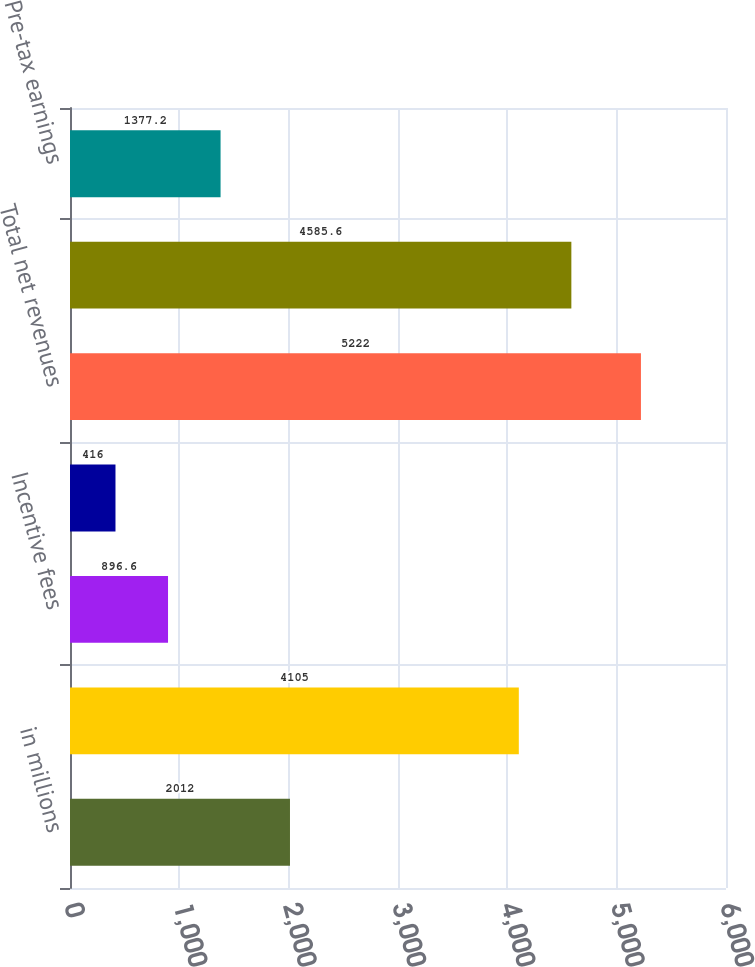Convert chart. <chart><loc_0><loc_0><loc_500><loc_500><bar_chart><fcel>in millions<fcel>Management and other fees<fcel>Incentive fees<fcel>Transaction revenues<fcel>Total net revenues<fcel>Operating expenses<fcel>Pre-tax earnings<nl><fcel>2012<fcel>4105<fcel>896.6<fcel>416<fcel>5222<fcel>4585.6<fcel>1377.2<nl></chart> 